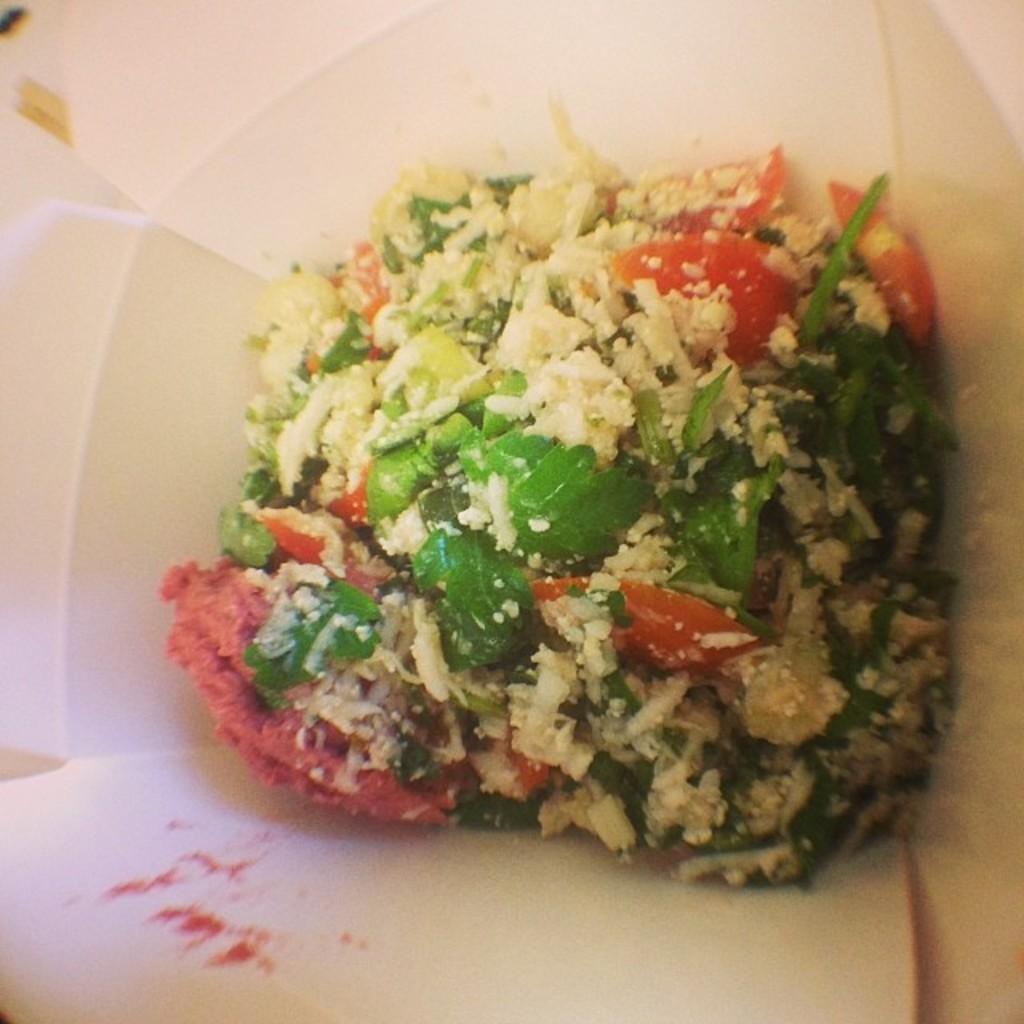Can you describe this image briefly? In the image we can see a plate, in the plate there is food. 